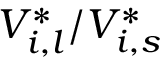<formula> <loc_0><loc_0><loc_500><loc_500>V _ { i , l } ^ { * } / V _ { i , s } ^ { * }</formula> 